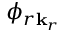<formula> <loc_0><loc_0><loc_500><loc_500>\phi _ { r \mathbf k _ { r } }</formula> 